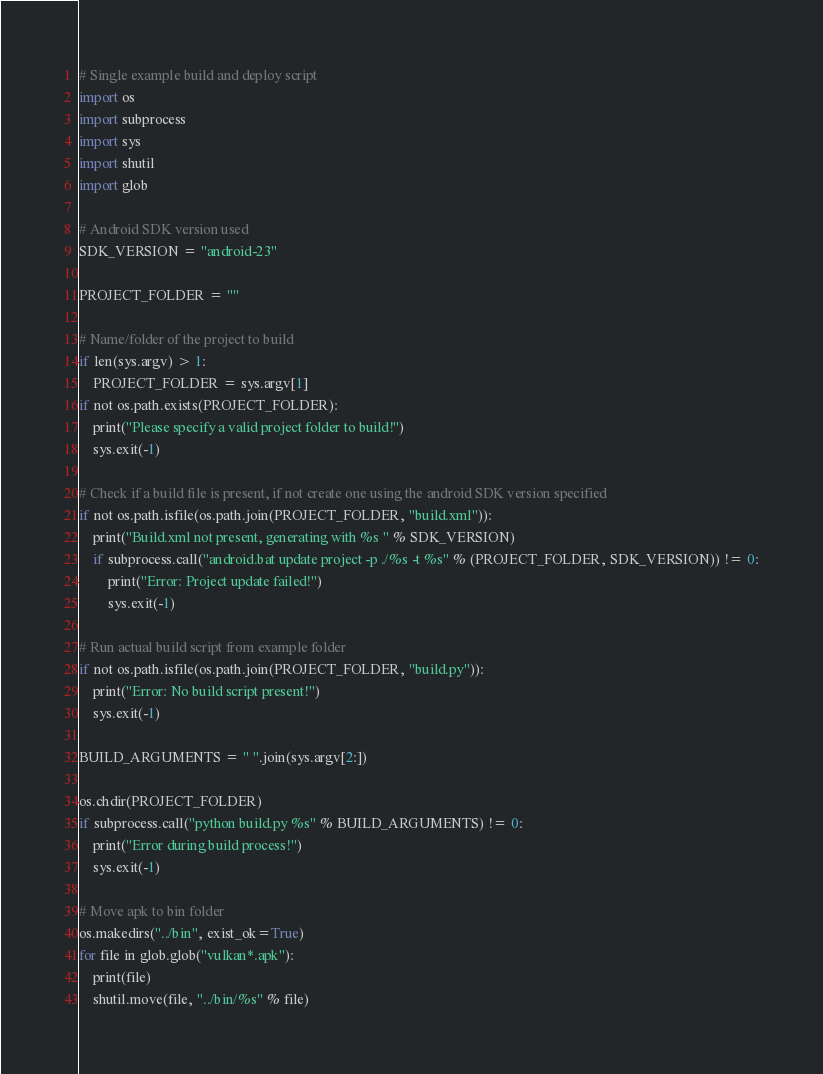Convert code to text. <code><loc_0><loc_0><loc_500><loc_500><_Python_># Single example build and deploy script
import os
import subprocess
import sys
import shutil
import glob

# Android SDK version used
SDK_VERSION = "android-23"

PROJECT_FOLDER = ""

# Name/folder of the project to build
if len(sys.argv) > 1:
    PROJECT_FOLDER = sys.argv[1]
if not os.path.exists(PROJECT_FOLDER):
    print("Please specify a valid project folder to build!")
    sys.exit(-1)

# Check if a build file is present, if not create one using the android SDK version specified
if not os.path.isfile(os.path.join(PROJECT_FOLDER, "build.xml")):
    print("Build.xml not present, generating with %s " % SDK_VERSION)
    if subprocess.call("android.bat update project -p ./%s -t %s" % (PROJECT_FOLDER, SDK_VERSION)) != 0:
        print("Error: Project update failed!")
        sys.exit(-1)

# Run actual build script from example folder
if not os.path.isfile(os.path.join(PROJECT_FOLDER, "build.py")):
    print("Error: No build script present!")
    sys.exit(-1)

BUILD_ARGUMENTS = " ".join(sys.argv[2:])

os.chdir(PROJECT_FOLDER)
if subprocess.call("python build.py %s" % BUILD_ARGUMENTS) != 0:
    print("Error during build process!")
    sys.exit(-1)

# Move apk to bin folder
os.makedirs("../bin", exist_ok=True)
for file in glob.glob("vulkan*.apk"):
    print(file)
    shutil.move(file, "../bin/%s" % file)
</code> 